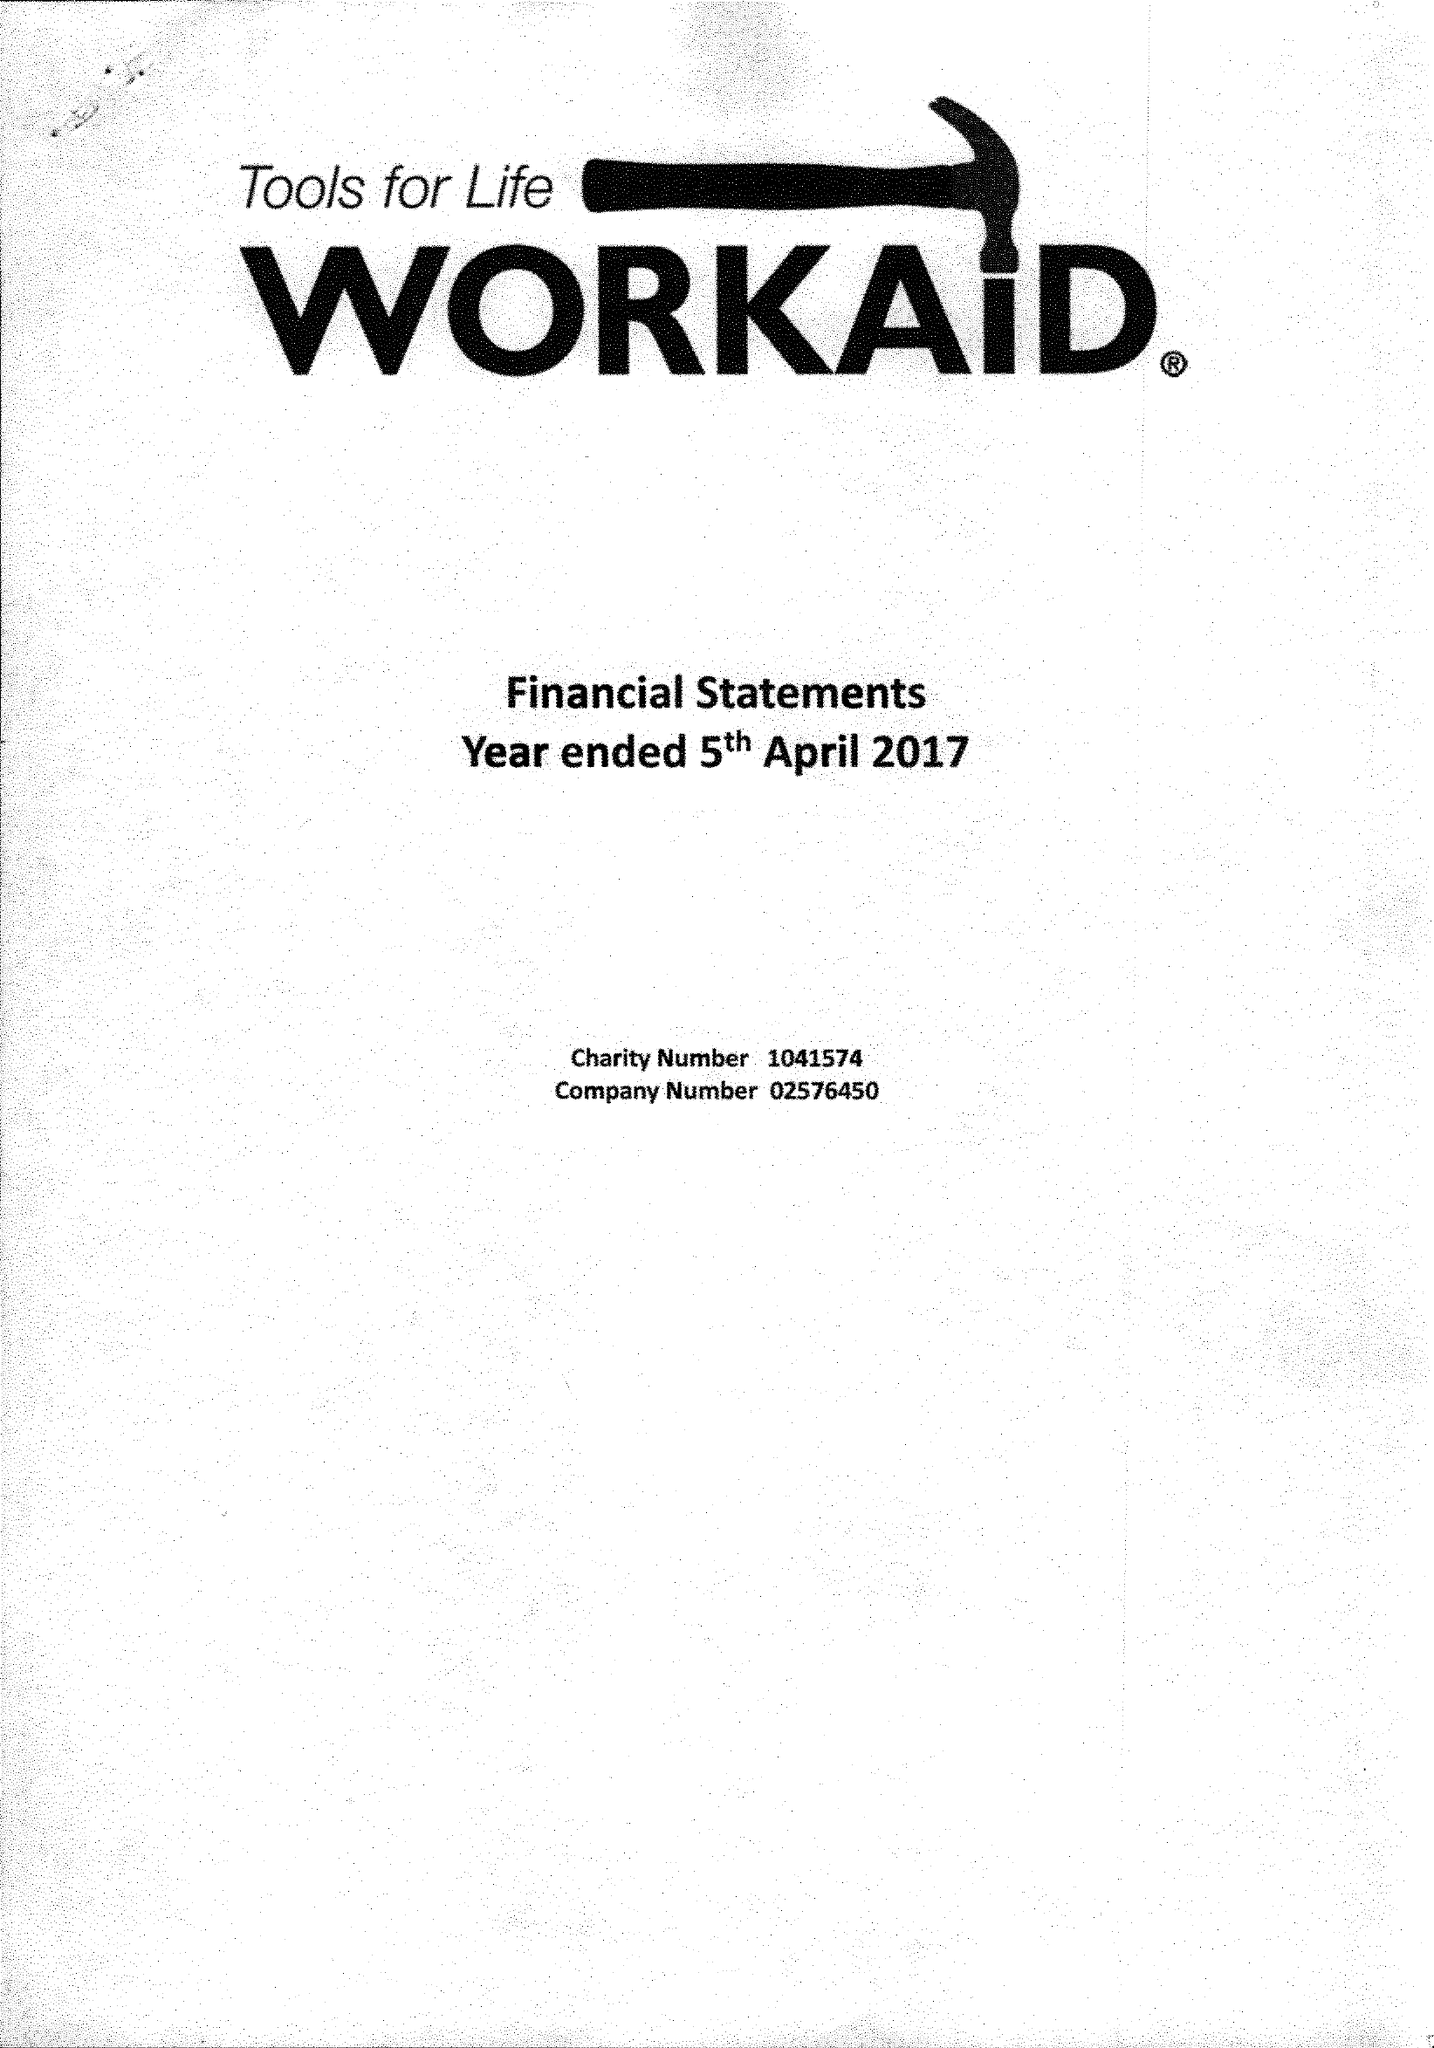What is the value for the income_annually_in_british_pounds?
Answer the question using a single word or phrase. 364294.00 